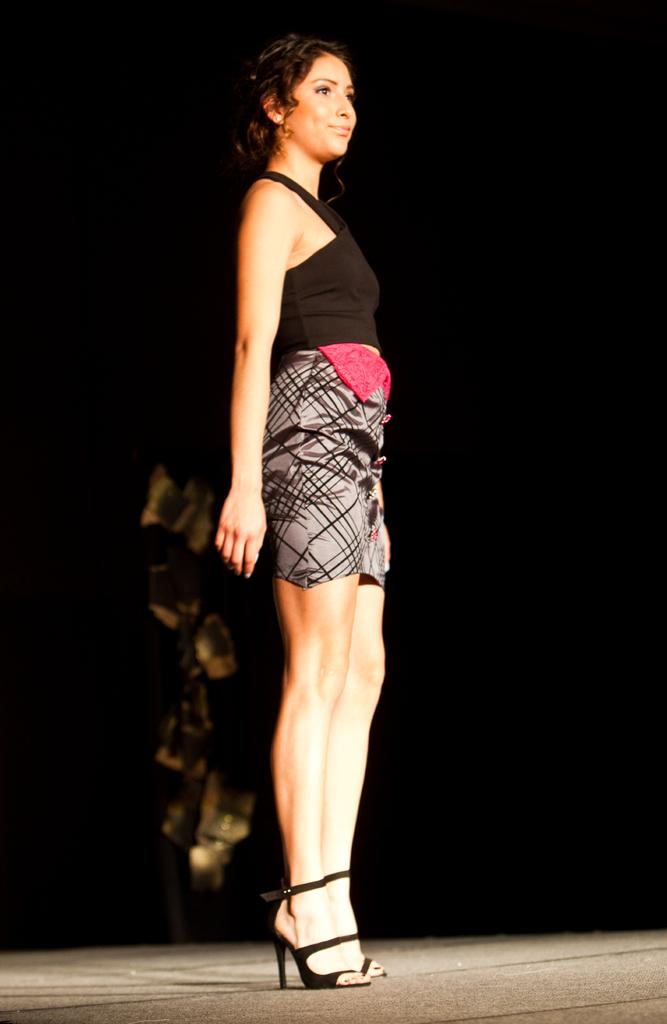What is the main subject of the image? The main subject of the image is a woman. Where is the woman located in the image? The woman is standing in the middle of the image. What is the woman standing on? The woman is standing on the floor. What color can be seen in the background of the image? There is a black color visible in the background of the image. Can you tell me how many teeth the giraffe has in the image? There is no giraffe present in the image, so it is not possible to determine the number of teeth it might have. 